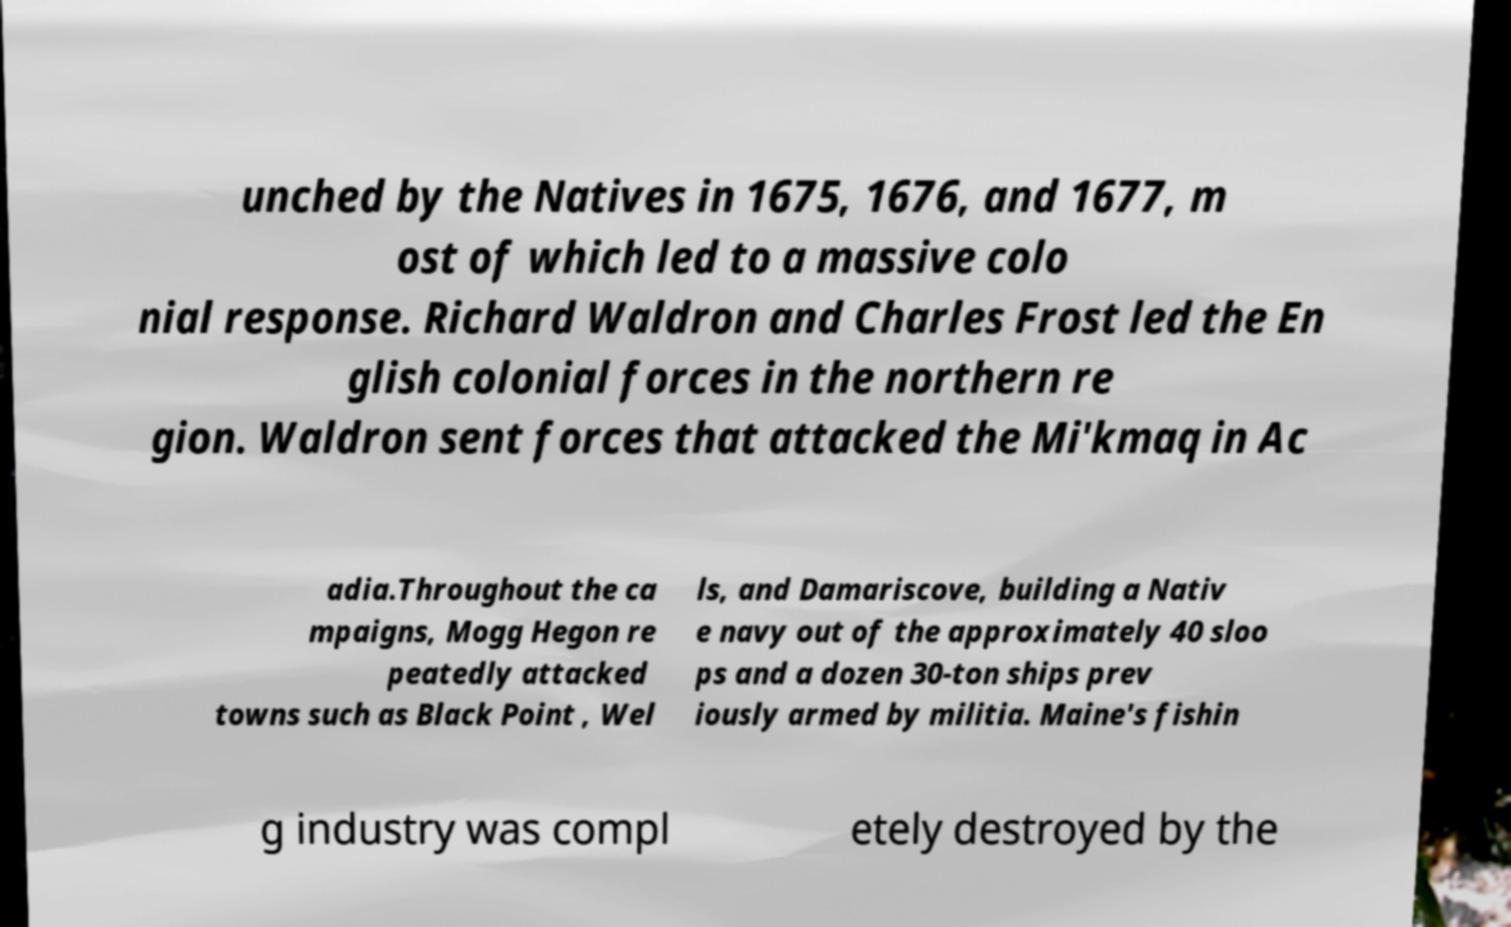Could you extract and type out the text from this image? unched by the Natives in 1675, 1676, and 1677, m ost of which led to a massive colo nial response. Richard Waldron and Charles Frost led the En glish colonial forces in the northern re gion. Waldron sent forces that attacked the Mi'kmaq in Ac adia.Throughout the ca mpaigns, Mogg Hegon re peatedly attacked towns such as Black Point , Wel ls, and Damariscove, building a Nativ e navy out of the approximately 40 sloo ps and a dozen 30-ton ships prev iously armed by militia. Maine's fishin g industry was compl etely destroyed by the 